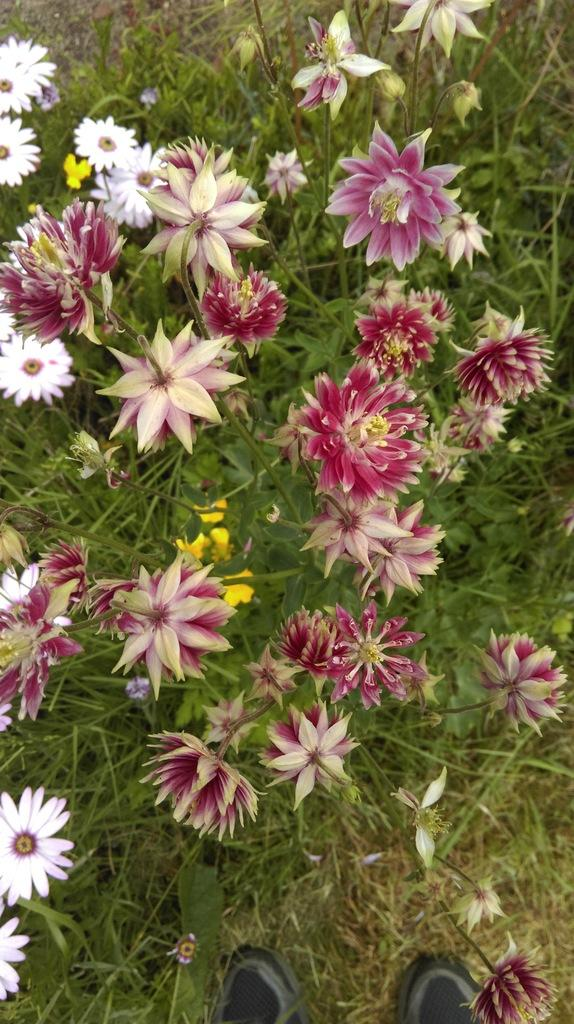What type of living organisms can be seen in the image? Plants are visible in the image. What specific features can be observed on the plants? Flowers are present on the plants. What type of surface is the shoes placed on? The shoes are visible on the grass. What is the price of the bead that the aunt is holding in the image? There is no bead or aunt present in the image; it only features plants and shoes on the grass. 